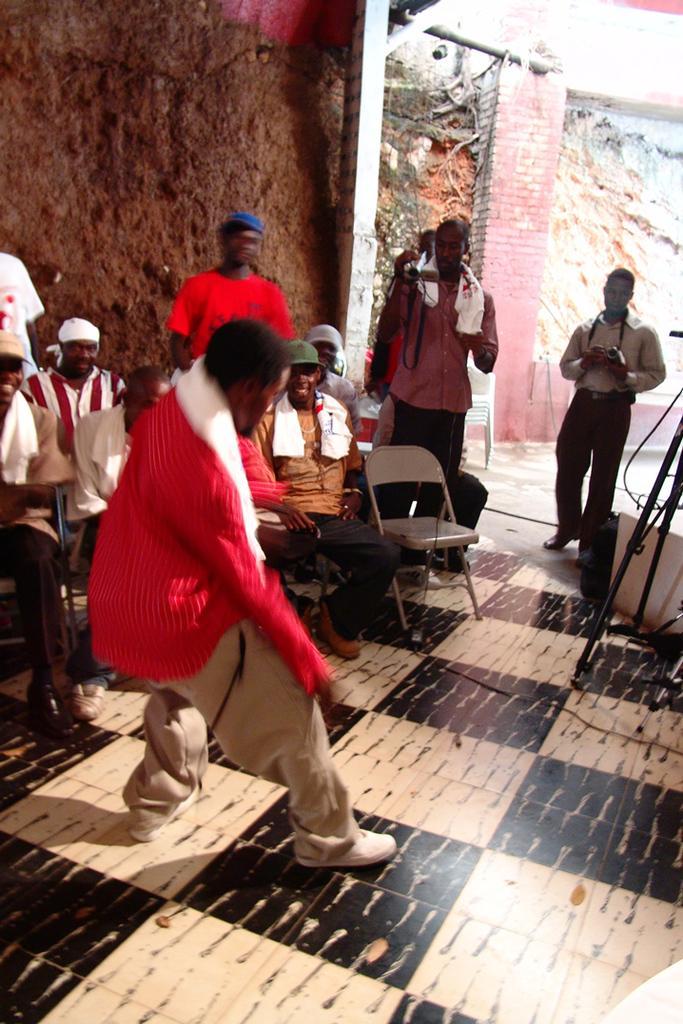How would you summarize this image in a sentence or two? In this image I can see few people are standing and few are sitting on chairs. Person is holding camera. Back I can see pillar. 